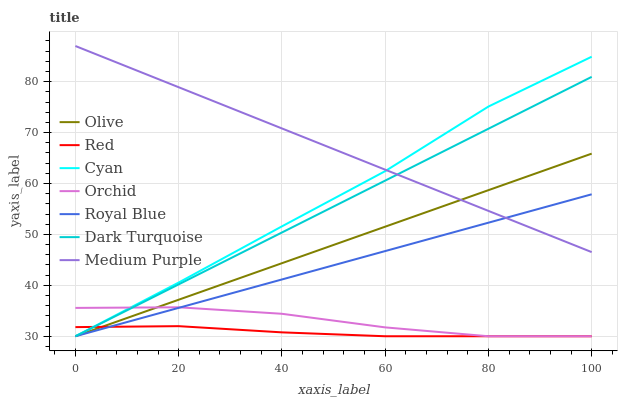Does Red have the minimum area under the curve?
Answer yes or no. Yes. Does Medium Purple have the maximum area under the curve?
Answer yes or no. Yes. Does Royal Blue have the minimum area under the curve?
Answer yes or no. No. Does Royal Blue have the maximum area under the curve?
Answer yes or no. No. Is Royal Blue the smoothest?
Answer yes or no. Yes. Is Orchid the roughest?
Answer yes or no. Yes. Is Medium Purple the smoothest?
Answer yes or no. No. Is Medium Purple the roughest?
Answer yes or no. No. Does Dark Turquoise have the lowest value?
Answer yes or no. Yes. Does Medium Purple have the lowest value?
Answer yes or no. No. Does Medium Purple have the highest value?
Answer yes or no. Yes. Does Royal Blue have the highest value?
Answer yes or no. No. Is Orchid less than Medium Purple?
Answer yes or no. Yes. Is Medium Purple greater than Orchid?
Answer yes or no. Yes. Does Cyan intersect Royal Blue?
Answer yes or no. Yes. Is Cyan less than Royal Blue?
Answer yes or no. No. Is Cyan greater than Royal Blue?
Answer yes or no. No. Does Orchid intersect Medium Purple?
Answer yes or no. No. 